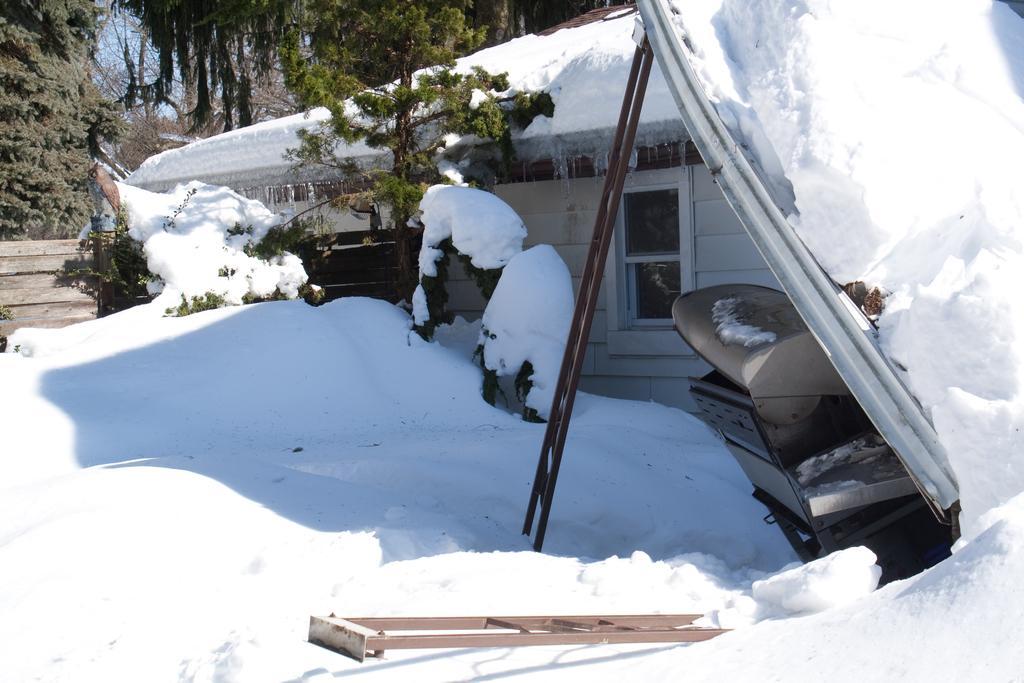In one or two sentences, can you explain what this image depicts? This picture is full of snow. Here we can see a house with snow over it. This is a tree. This is a door. Here we can see a ladder which is brown in colour. On the background of the picture we can see trees. 